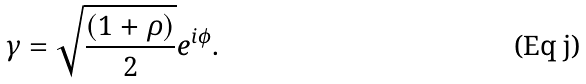Convert formula to latex. <formula><loc_0><loc_0><loc_500><loc_500>\gamma = \sqrt { \frac { ( 1 + \rho ) } { 2 } } e ^ { i \phi } .</formula> 